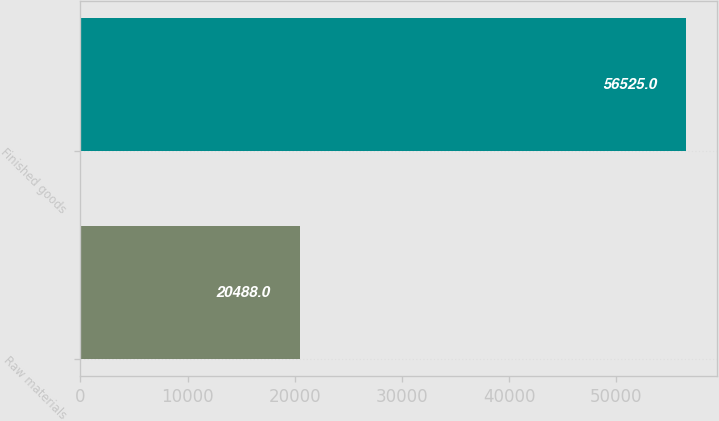Convert chart. <chart><loc_0><loc_0><loc_500><loc_500><bar_chart><fcel>Raw materials<fcel>Finished goods<nl><fcel>20488<fcel>56525<nl></chart> 